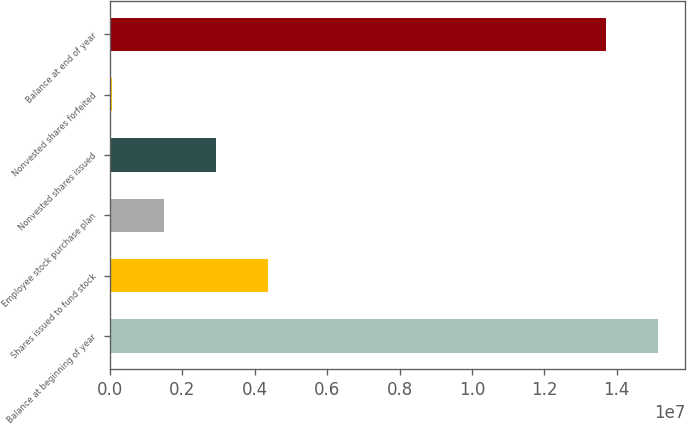Convert chart. <chart><loc_0><loc_0><loc_500><loc_500><bar_chart><fcel>Balance at beginning of year<fcel>Shares issued to fund stock<fcel>Employee stock purchase plan<fcel>Nonvested shares issued<fcel>Nonvested shares forfeited<fcel>Balance at end of year<nl><fcel>1.51336e+07<fcel>4.3589e+06<fcel>1.49867e+06<fcel>2.92879e+06<fcel>68552<fcel>1.37035e+07<nl></chart> 